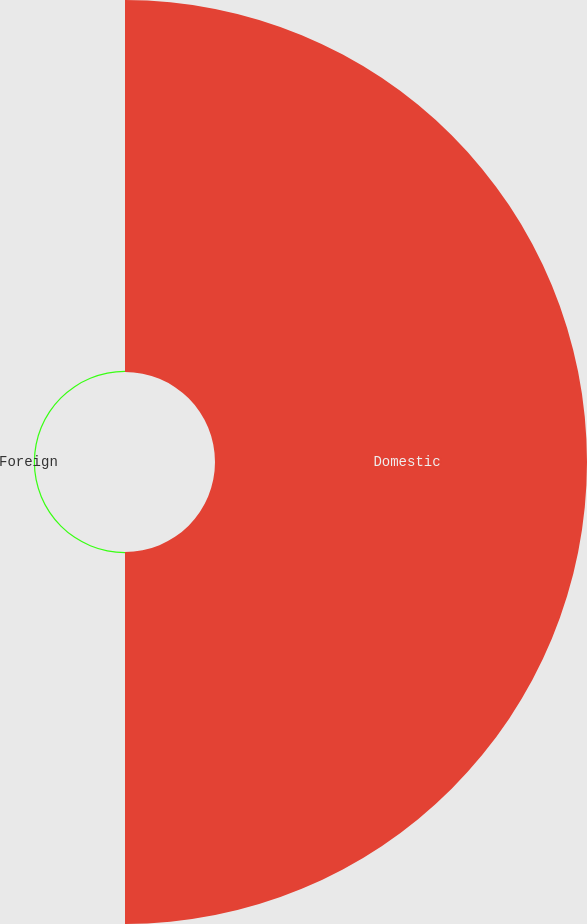<chart> <loc_0><loc_0><loc_500><loc_500><pie_chart><fcel>Domestic<fcel>Foreign<nl><fcel>99.67%<fcel>0.33%<nl></chart> 